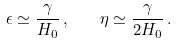<formula> <loc_0><loc_0><loc_500><loc_500>\epsilon \simeq \frac { \gamma } { H _ { 0 } } \, , \quad \eta \simeq \frac { \gamma } { 2 H _ { 0 } } \, .</formula> 